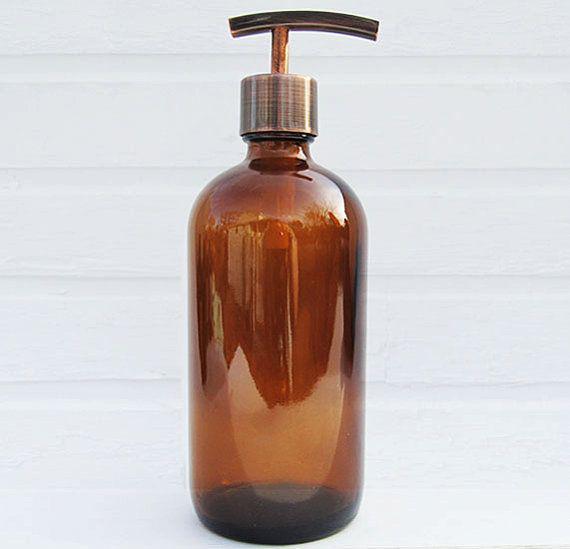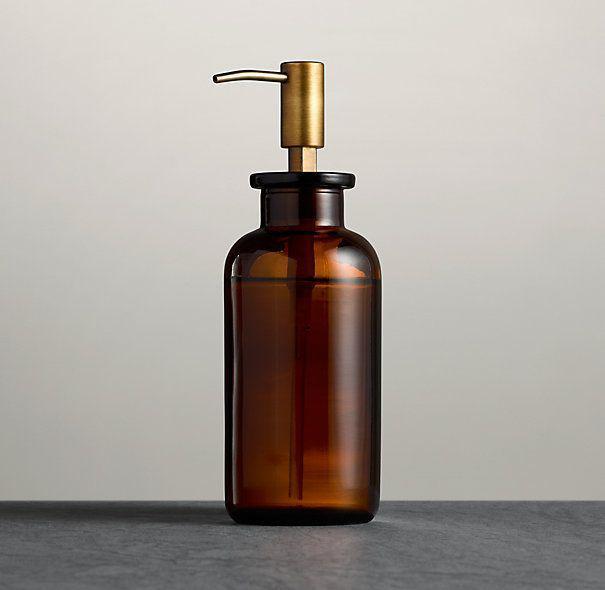The first image is the image on the left, the second image is the image on the right. Analyze the images presented: Is the assertion "The nozzle of the dispenser in the right image is pointed towards the right." valid? Answer yes or no. No. The first image is the image on the left, the second image is the image on the right. Evaluate the accuracy of this statement regarding the images: "There is a plant to the left of one of the bottles, and one of the bottles is on a wooden surface.". Is it true? Answer yes or no. No. 